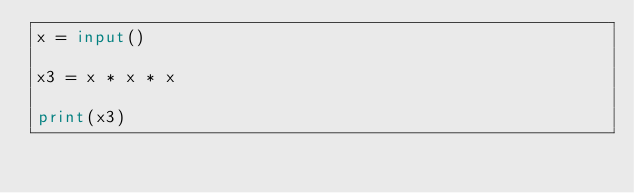Convert code to text. <code><loc_0><loc_0><loc_500><loc_500><_Python_>x = input()

x3 = x * x * x

print(x3)</code> 